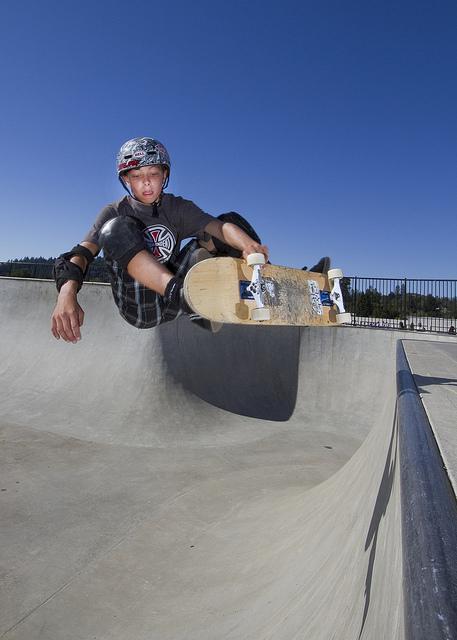How many bikes are there?
Give a very brief answer. 0. 